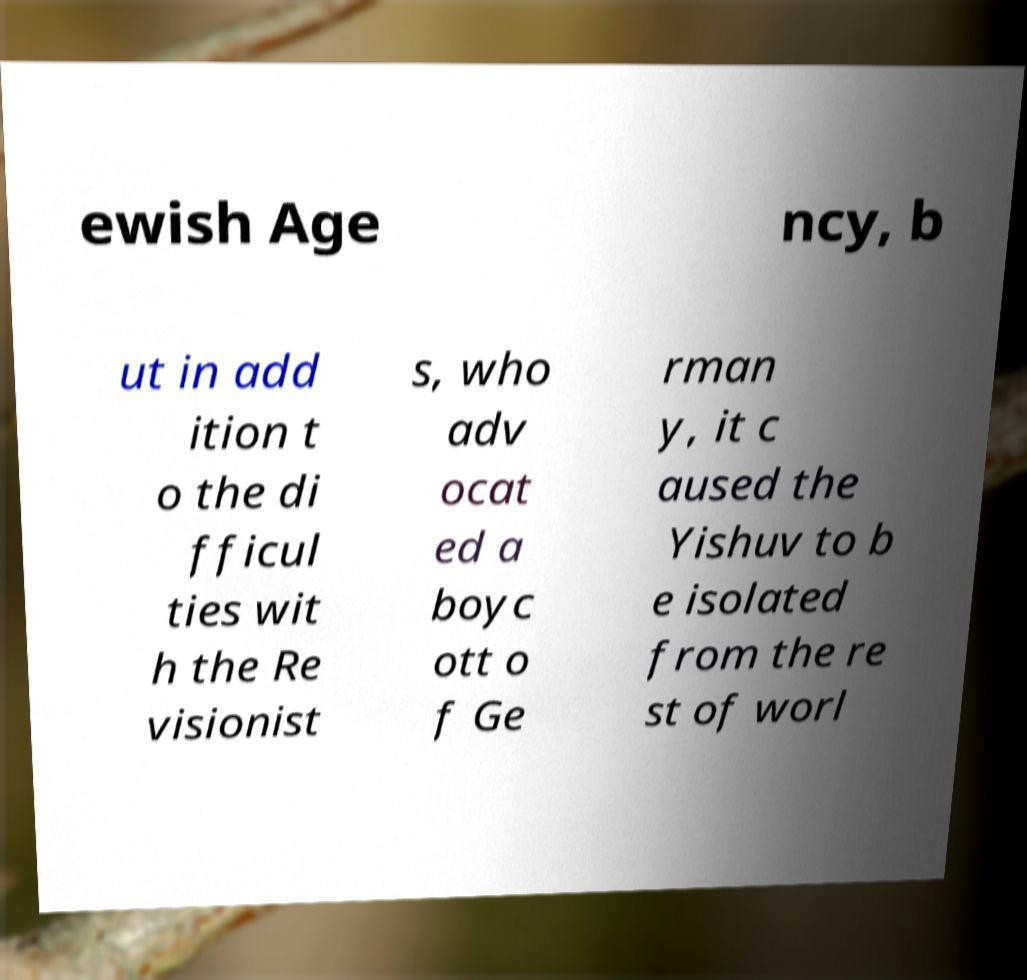Could you assist in decoding the text presented in this image and type it out clearly? ewish Age ncy, b ut in add ition t o the di fficul ties wit h the Re visionist s, who adv ocat ed a boyc ott o f Ge rman y, it c aused the Yishuv to b e isolated from the re st of worl 